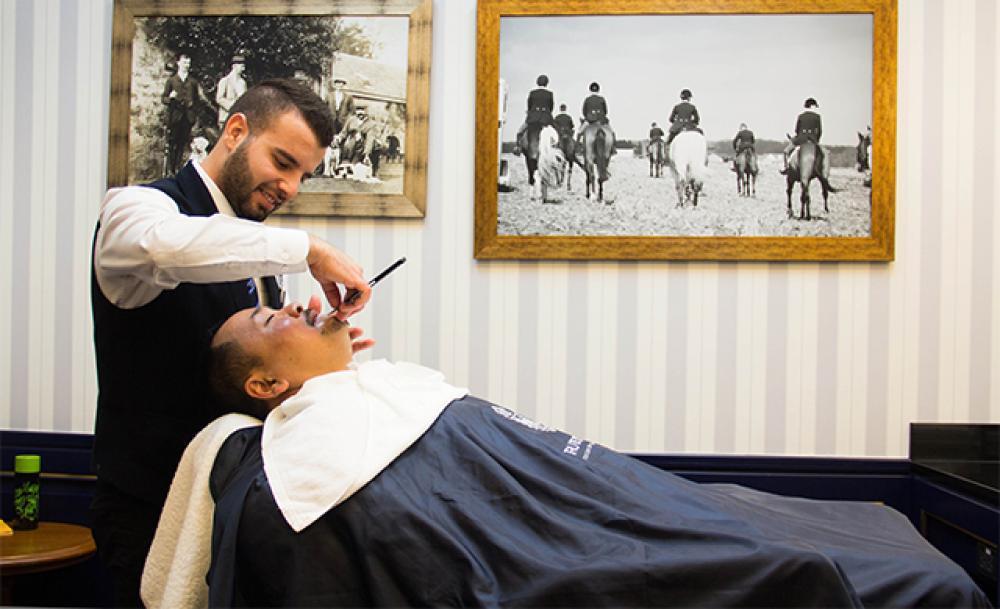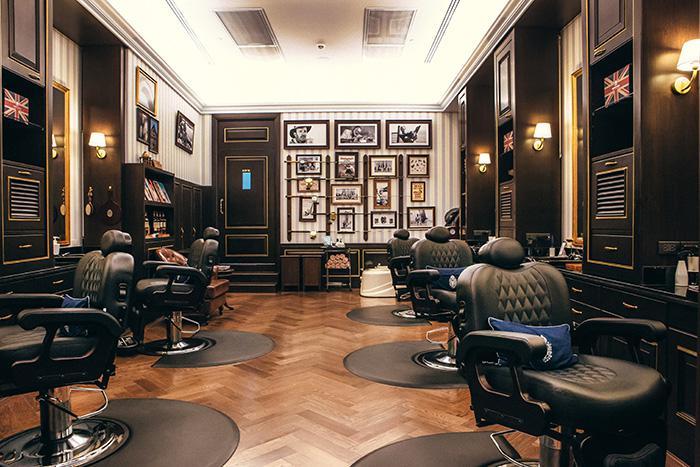The first image is the image on the left, the second image is the image on the right. Examine the images to the left and right. Is the description "One image features the barbershop storefront, and they have the same name." accurate? Answer yes or no. No. The first image is the image on the left, the second image is the image on the right. Evaluate the accuracy of this statement regarding the images: "There are men in black vests working on a customer in a barber chair.". Is it true? Answer yes or no. Yes. 